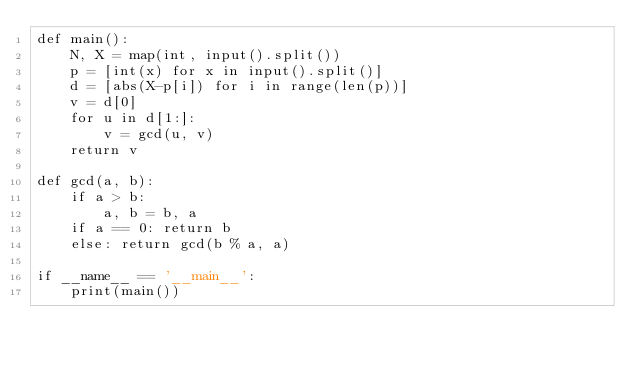<code> <loc_0><loc_0><loc_500><loc_500><_Python_>def main():
    N, X = map(int, input().split())
    p = [int(x) for x in input().split()]
    d = [abs(X-p[i]) for i in range(len(p))]
    v = d[0]
    for u in d[1:]:
        v = gcd(u, v)
    return v

def gcd(a, b):
    if a > b:
        a, b = b, a
    if a == 0: return b
    else: return gcd(b % a, a)

if __name__ == '__main__':
    print(main())</code> 